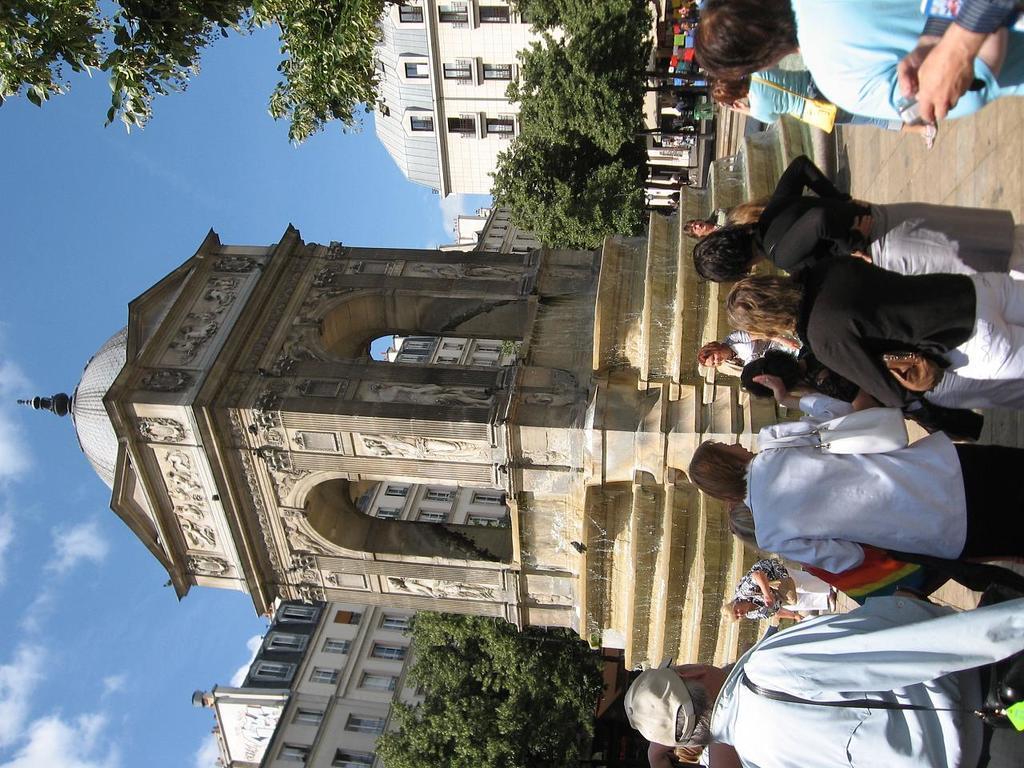Describe this image in one or two sentences. In this image I can see number of persons are standing on the ground and a structure which is cream, black and ash in color and some water flowing through it. In the background I can see few trees, few buildings and the sky. 